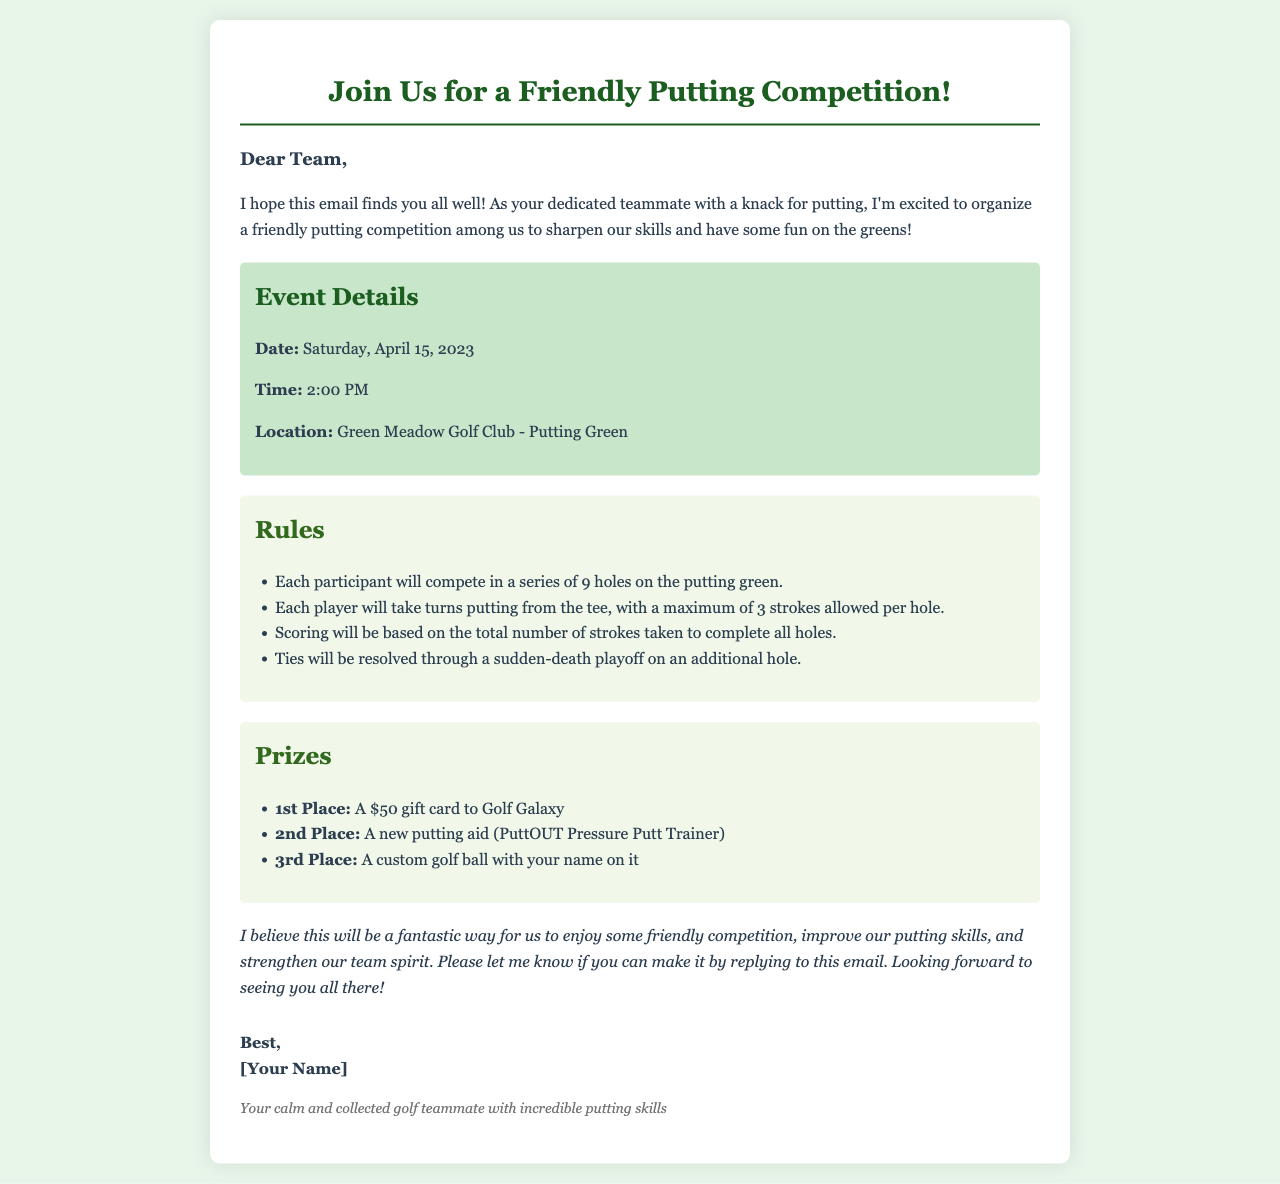What is the date of the event? The date of the event is specified in the event details section of the document.
Answer: Saturday, April 15, 2023 What is the first prize for the putting competition? The first prize is specified under the prizes section of the document.
Answer: A $50 gift card to Golf Galaxy Where will the putting competition take place? The location is given in the event details section of the document.
Answer: Green Meadow Golf Club - Putting Green How many strokes are allowed per hole? The maximum number of strokes allowed per hole is listed in the rules section.
Answer: 3 strokes What happens in case of a tie? The procedure for resolving a tie is outlined in the rules section of the document.
Answer: Sudden-death playoff What is the time of the event? The time of the event can be found in the event details section of the document.
Answer: 2:00 PM What is the second prize? The second prize is mentioned under the prizes section of the document.
Answer: A new putting aid (PuttOUT Pressure Putt Trainer) Who is organizing the competition? The organizer of the competition is mentioned in the greeting at the beginning of the email.
Answer: [Your Name] How many holes will participants compete on? The number of holes for the competition is stated in the rules section of the document.
Answer: 9 holes 